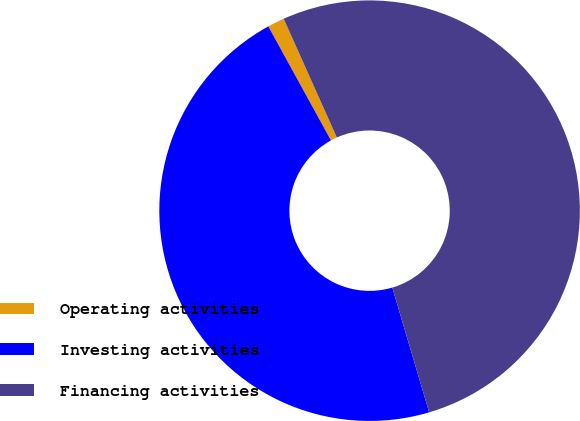<chart> <loc_0><loc_0><loc_500><loc_500><pie_chart><fcel>Operating activities<fcel>Investing activities<fcel>Financing activities<nl><fcel>1.3%<fcel>46.57%<fcel>52.12%<nl></chart> 